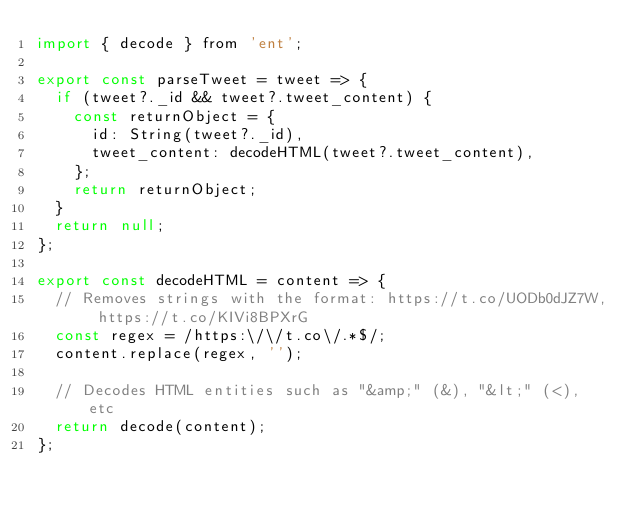<code> <loc_0><loc_0><loc_500><loc_500><_JavaScript_>import { decode } from 'ent';

export const parseTweet = tweet => {
  if (tweet?._id && tweet?.tweet_content) {
    const returnObject = {
      id: String(tweet?._id),
      tweet_content: decodeHTML(tweet?.tweet_content),
    };
    return returnObject;
  }
  return null;
};

export const decodeHTML = content => {
  // Removes strings with the format: https://t.co/UODb0dJZ7W, https://t.co/KIVi8BPXrG
  const regex = /https:\/\/t.co\/.*$/;
  content.replace(regex, '');

  // Decodes HTML entities such as "&amp;" (&), "&lt;" (<), etc
  return decode(content);
};
</code> 